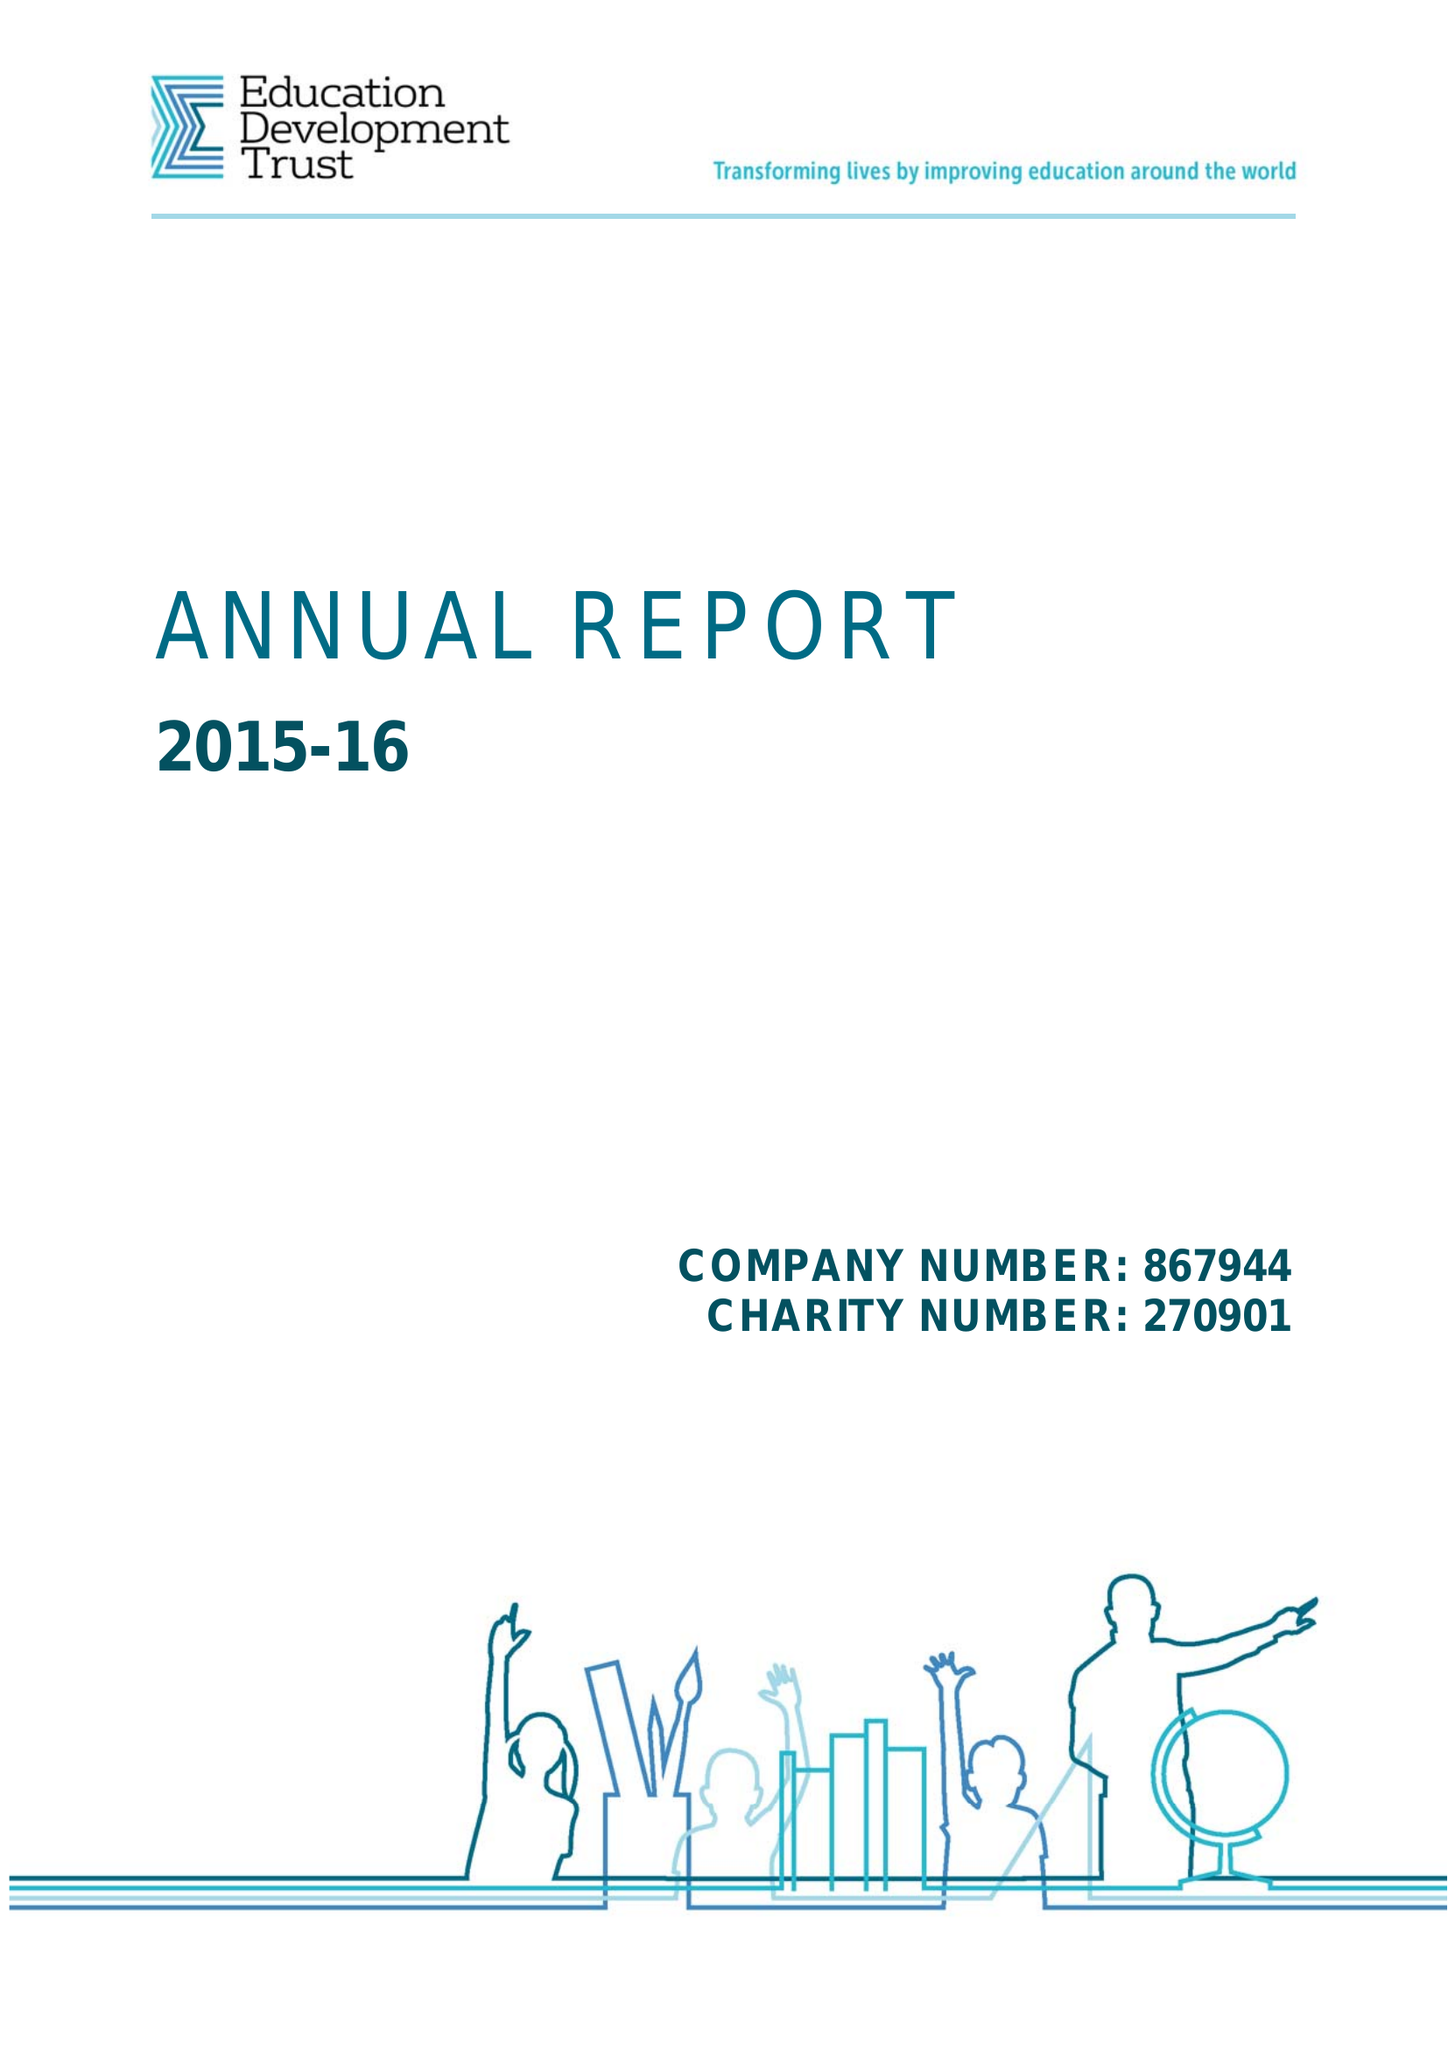What is the value for the spending_annually_in_british_pounds?
Answer the question using a single word or phrase. 68081000.00 